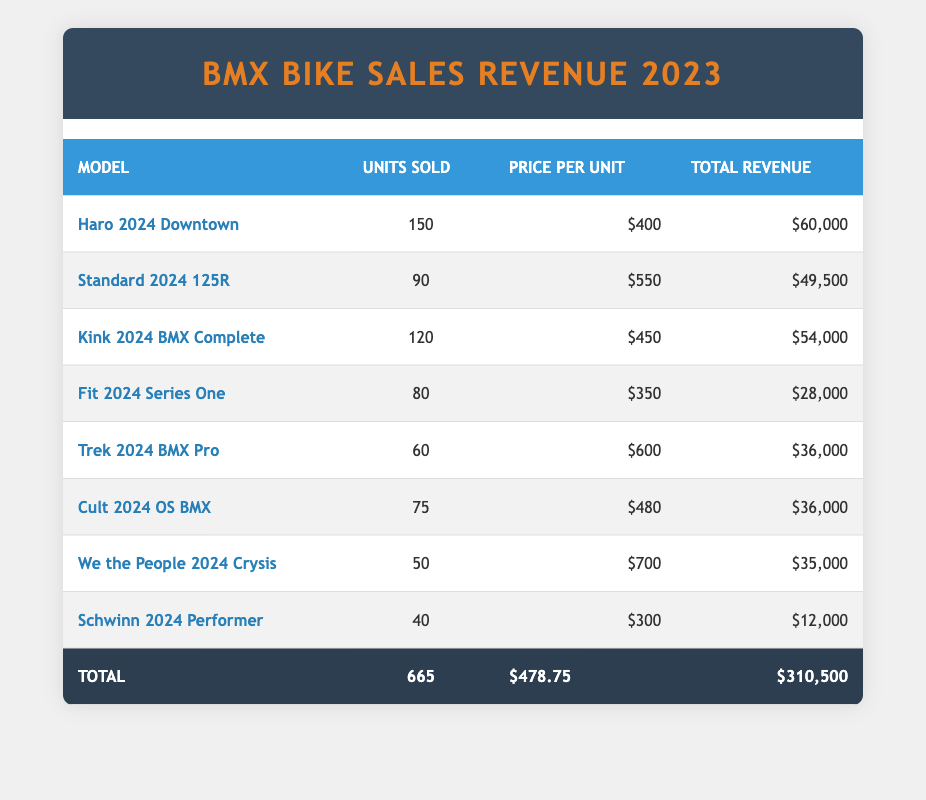What is the total revenue generated from Haro 2024 Downtown sales? From the table, the total revenue for Haro 2024 Downtown is listed directly under the "Total Revenue" column as $60,000.
Answer: $60,000 How many units of the Standard 2024 125R were sold? The table shows that the units sold for the Standard 2024 125R are listed as 90 under the "Units Sold" column.
Answer: 90 Which BMX bike model had the highest total revenue in 2023? By reviewing the "Total Revenue" column, Haro 2024 Downtown has the highest revenue of $60,000, which is greater than all other models.
Answer: Haro 2024 Downtown What is the average price per unit of all BMX bike models sold? To find the average price per unit, I will sum the price per unit for all models (400 + 550 + 450 + 350 + 600 + 480 + 700 + 300 = 3880) and divide by the number of models (8). The average price is 3880 / 8 = 485.
Answer: $485 Did the Fit 2024 Series One generate more revenue than the Trek 2024 BMX Pro? The total revenue for Fit 2024 Series One is $28,000 and for Trek 2024 BMX Pro is $36,000. Since $28,000 is less than $36,000, the answer is no.
Answer: No What is the combined total revenue of the Kink 2024 BMX Complete and Cult 2024 OS BMX? The total revenue for Kink 2024 BMX Complete is $54,000 and for Cult 2024 OS BMX is $36,000. Adding these values together gives $54,000 + $36,000 = $90,000.
Answer: $90,000 Are there more than 600 total units sold across all bike models? The table shows a total of 665 units sold, which is greater than 600. Thus, the answer is yes.
Answer: Yes What percentage of the total revenue comes from the top three models (Haro 2024 Downtown, Standard 2024 125R, and Kink 2024 BMX Complete)? The total revenue for the top three models is $60,000 (Haro) + $49,500 (Standard) + $54,000 (Kink) = $163,500. The total revenue for all models is $310,500. The percentage is (163,500 / 310,500) * 100 = 52.6%.
Answer: 52.6% Which bike model has the lowest total revenue? By comparing the "Total Revenue" for each model, Schwinn 2024 Performer has the lowest revenue at $12,000.
Answer: Schwinn 2024 Performer 